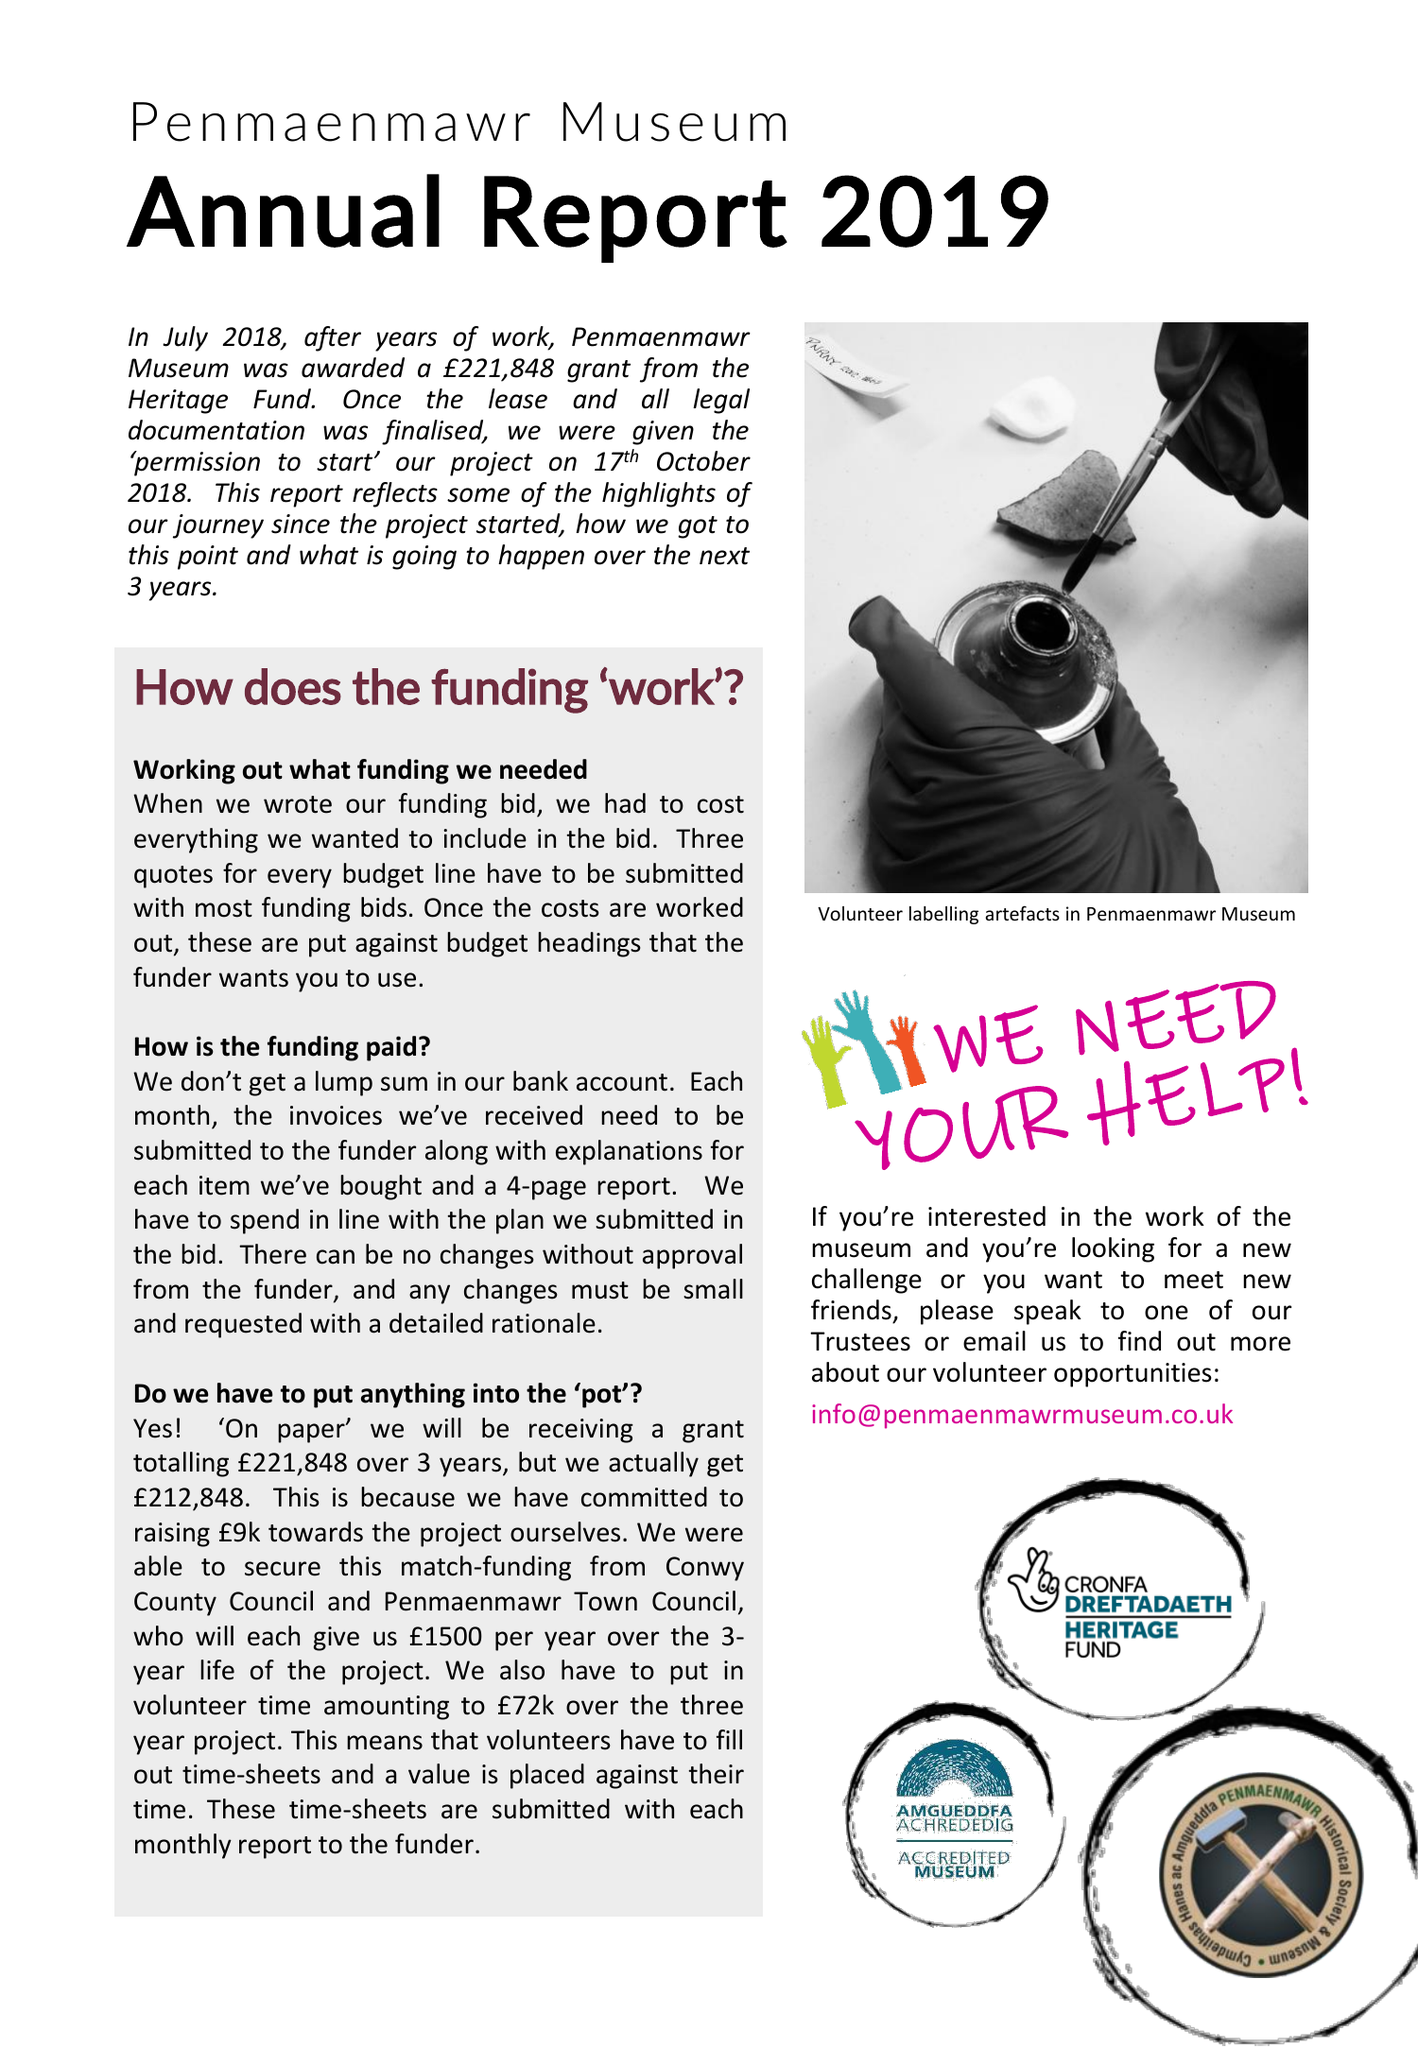What is the value for the charity_name?
Answer the question using a single word or phrase. Penmaenmawr Historical Society and Museum 